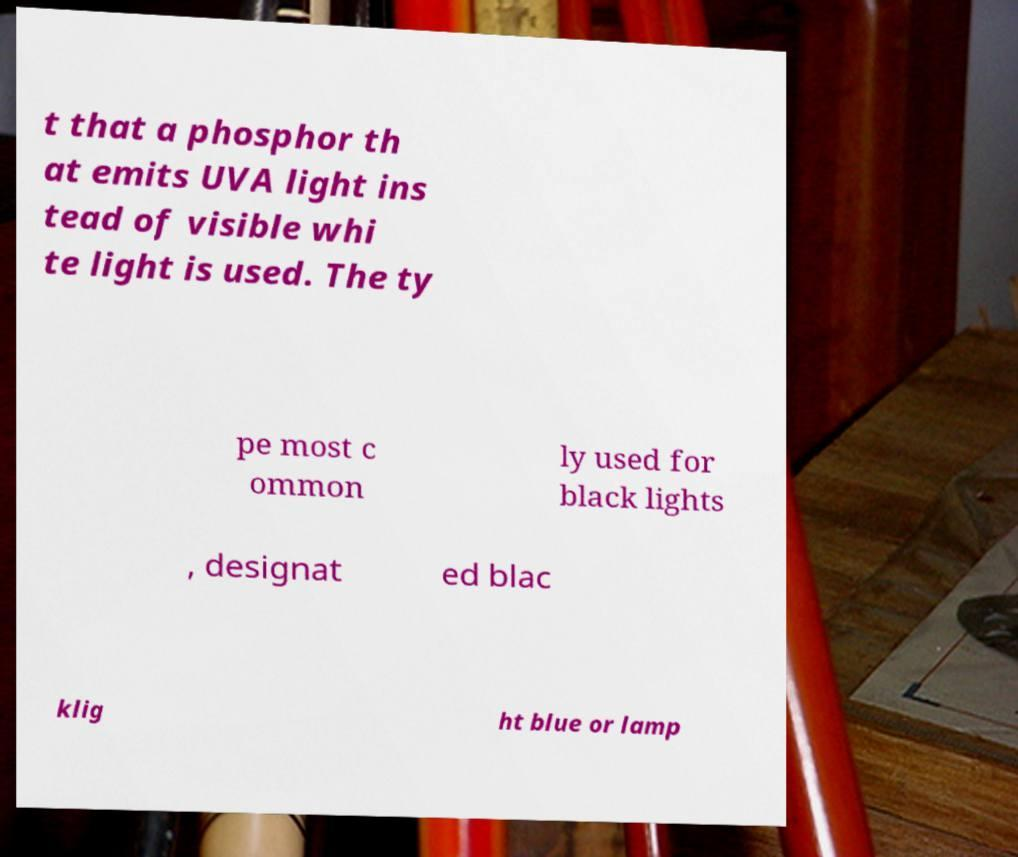There's text embedded in this image that I need extracted. Can you transcribe it verbatim? t that a phosphor th at emits UVA light ins tead of visible whi te light is used. The ty pe most c ommon ly used for black lights , designat ed blac klig ht blue or lamp 